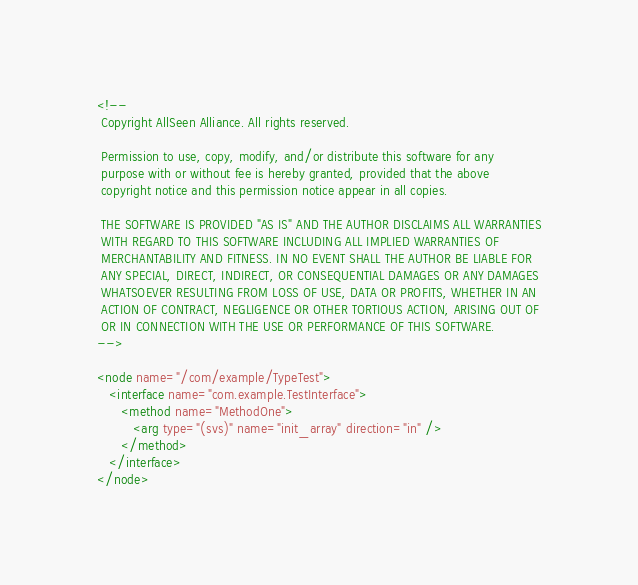<code> <loc_0><loc_0><loc_500><loc_500><_XML_><!--
 Copyright AllSeen Alliance. All rights reserved.

 Permission to use, copy, modify, and/or distribute this software for any
 purpose with or without fee is hereby granted, provided that the above
 copyright notice and this permission notice appear in all copies.

 THE SOFTWARE IS PROVIDED "AS IS" AND THE AUTHOR DISCLAIMS ALL WARRANTIES
 WITH REGARD TO THIS SOFTWARE INCLUDING ALL IMPLIED WARRANTIES OF
 MERCHANTABILITY AND FITNESS. IN NO EVENT SHALL THE AUTHOR BE LIABLE FOR
 ANY SPECIAL, DIRECT, INDIRECT, OR CONSEQUENTIAL DAMAGES OR ANY DAMAGES
 WHATSOEVER RESULTING FROM LOSS OF USE, DATA OR PROFITS, WHETHER IN AN
 ACTION OF CONTRACT, NEGLIGENCE OR OTHER TORTIOUS ACTION, ARISING OUT OF
 OR IN CONNECTION WITH THE USE OR PERFORMANCE OF THIS SOFTWARE.
-->

<node name="/com/example/TypeTest">
   <interface name="com.example.TestInterface">
      <method name="MethodOne">
         <arg type="(svs)" name="init_array" direction="in" />
      </method>
   </interface>
</node>

</code> 